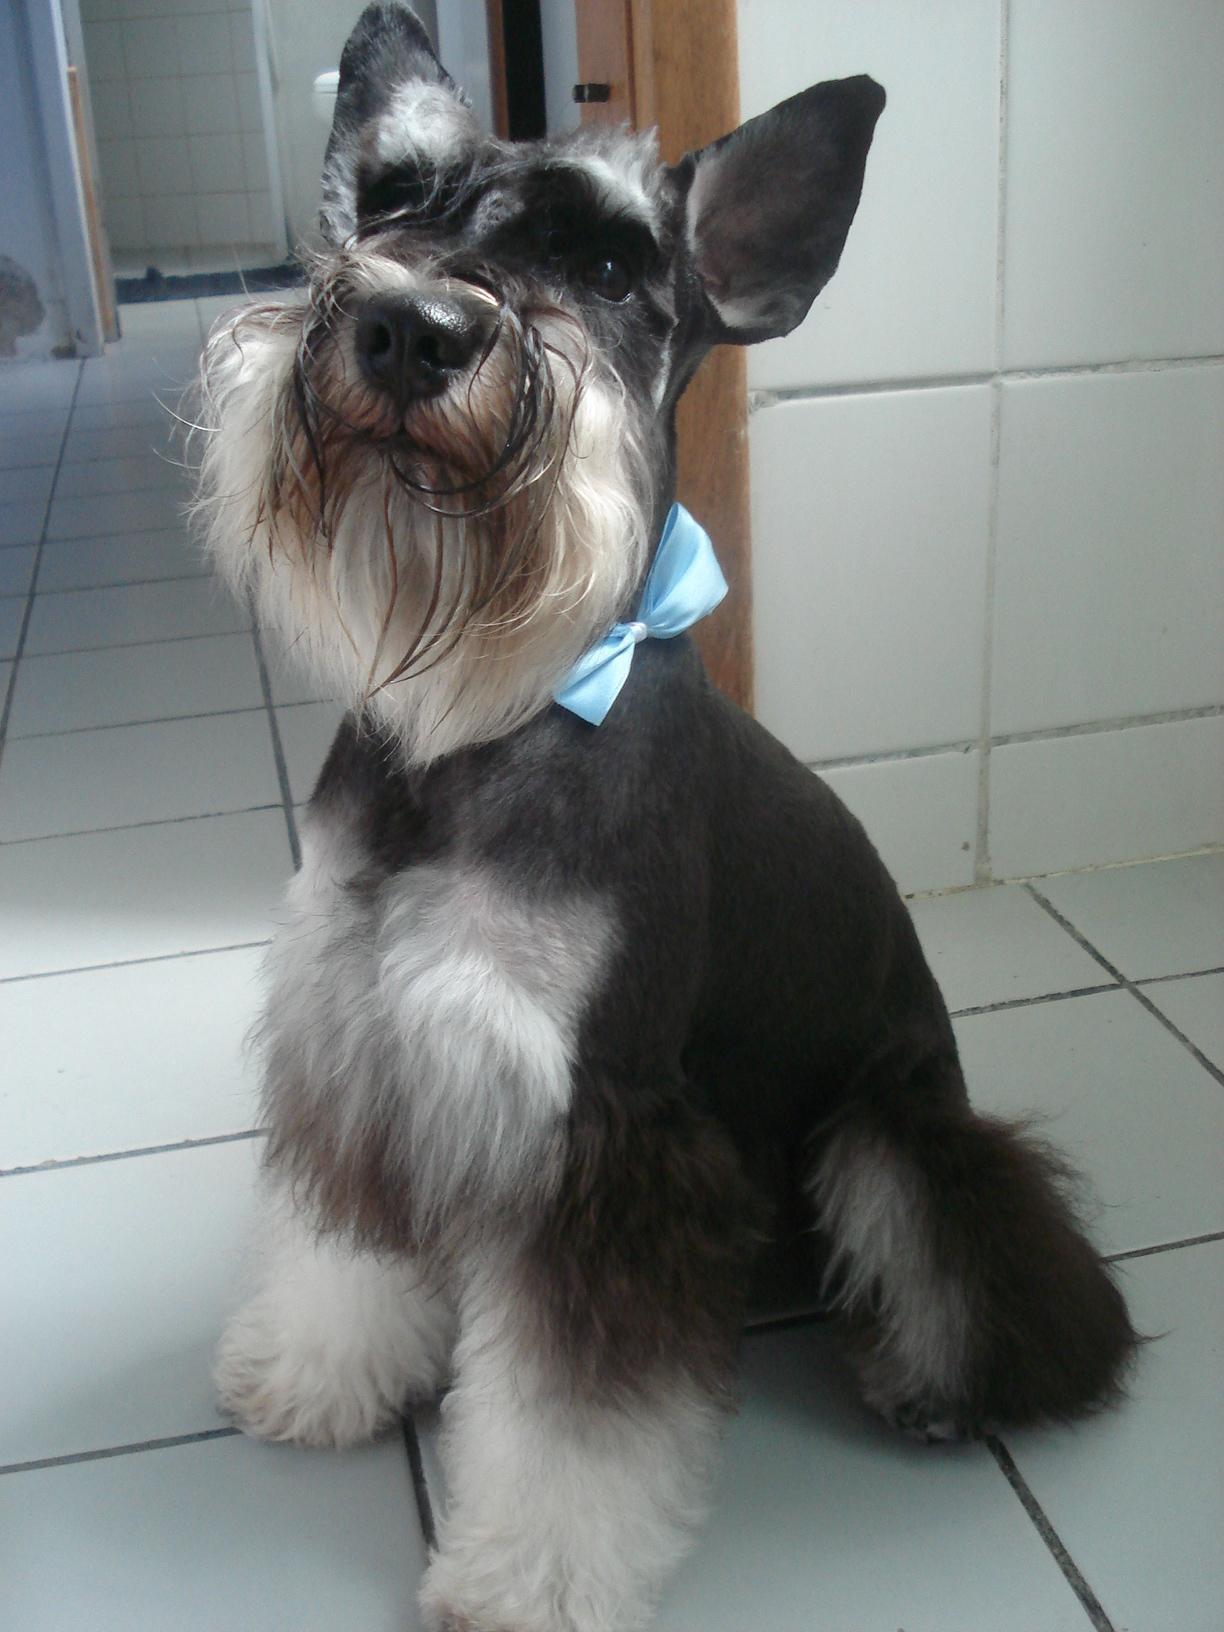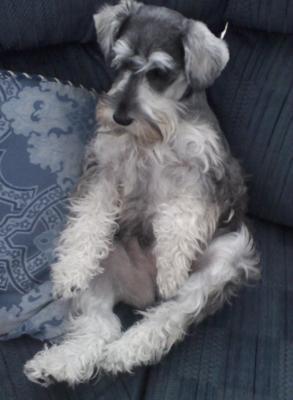The first image is the image on the left, the second image is the image on the right. For the images shown, is this caption "The dog in the image on the left is wearing a collar." true? Answer yes or no. Yes. The first image is the image on the left, the second image is the image on the right. Evaluate the accuracy of this statement regarding the images: "An image shows one schnauzer dog on a piece of upholstered furniture, next to a soft object.". Is it true? Answer yes or no. Yes. 